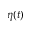<formula> <loc_0><loc_0><loc_500><loc_500>\eta ( t )</formula> 